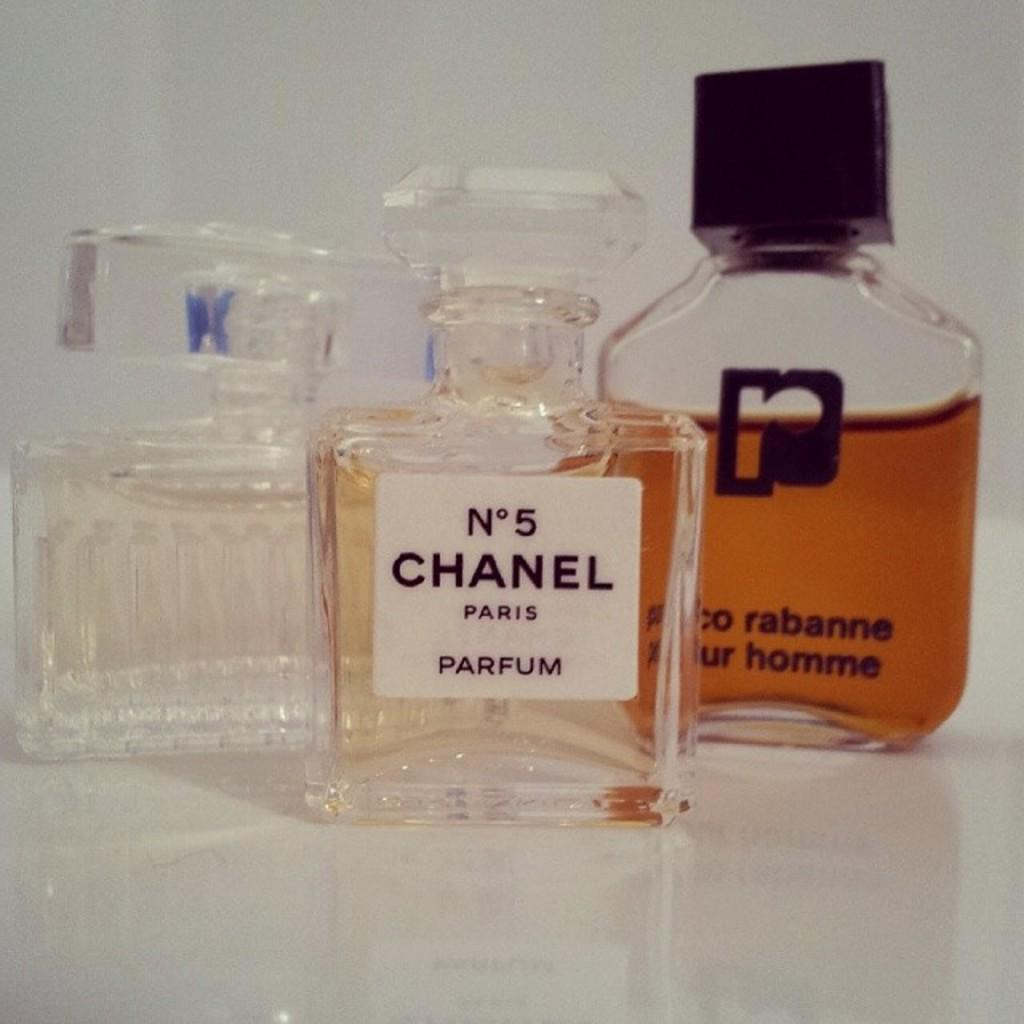Provide a one-sentence caption for the provided image. A bottle of Chanel No. 5 is on a table with two other perfume bottles. 